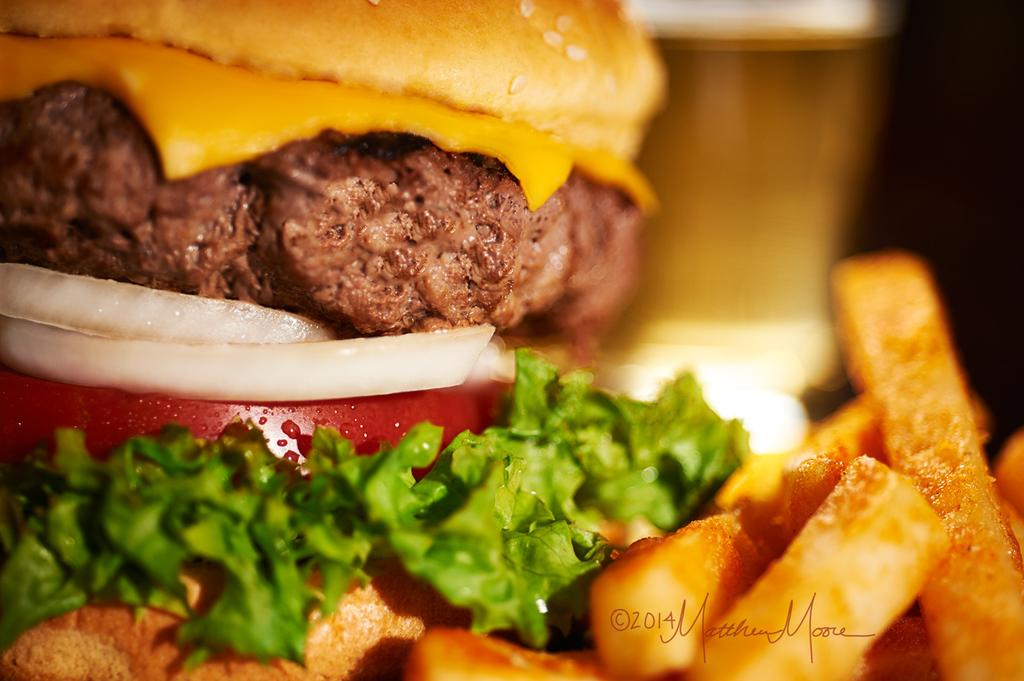What can be seen in the image related to food? There is food in the image. Can you describe the background of the image? The background of the image is blurry. How many birds are in the flock that is visible in the image? There is no flock of birds visible in the image; it only features food and a blurry background. 